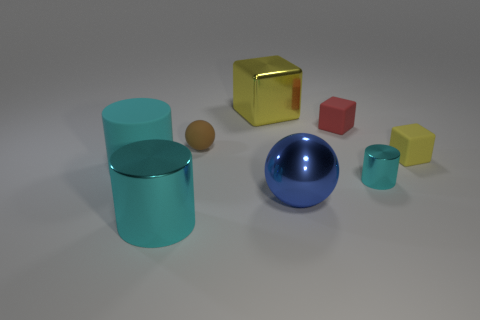What material is the yellow cube that is to the left of the yellow block that is in front of the metallic thing behind the red block? The yellow cube to the left of the yellow block, which is situated in front of the metallic cylinder behind the red cube, appears to be made of the same shiny, reflective material as the metallic cylinder, suggesting it could also be metal with a yellow finish. 